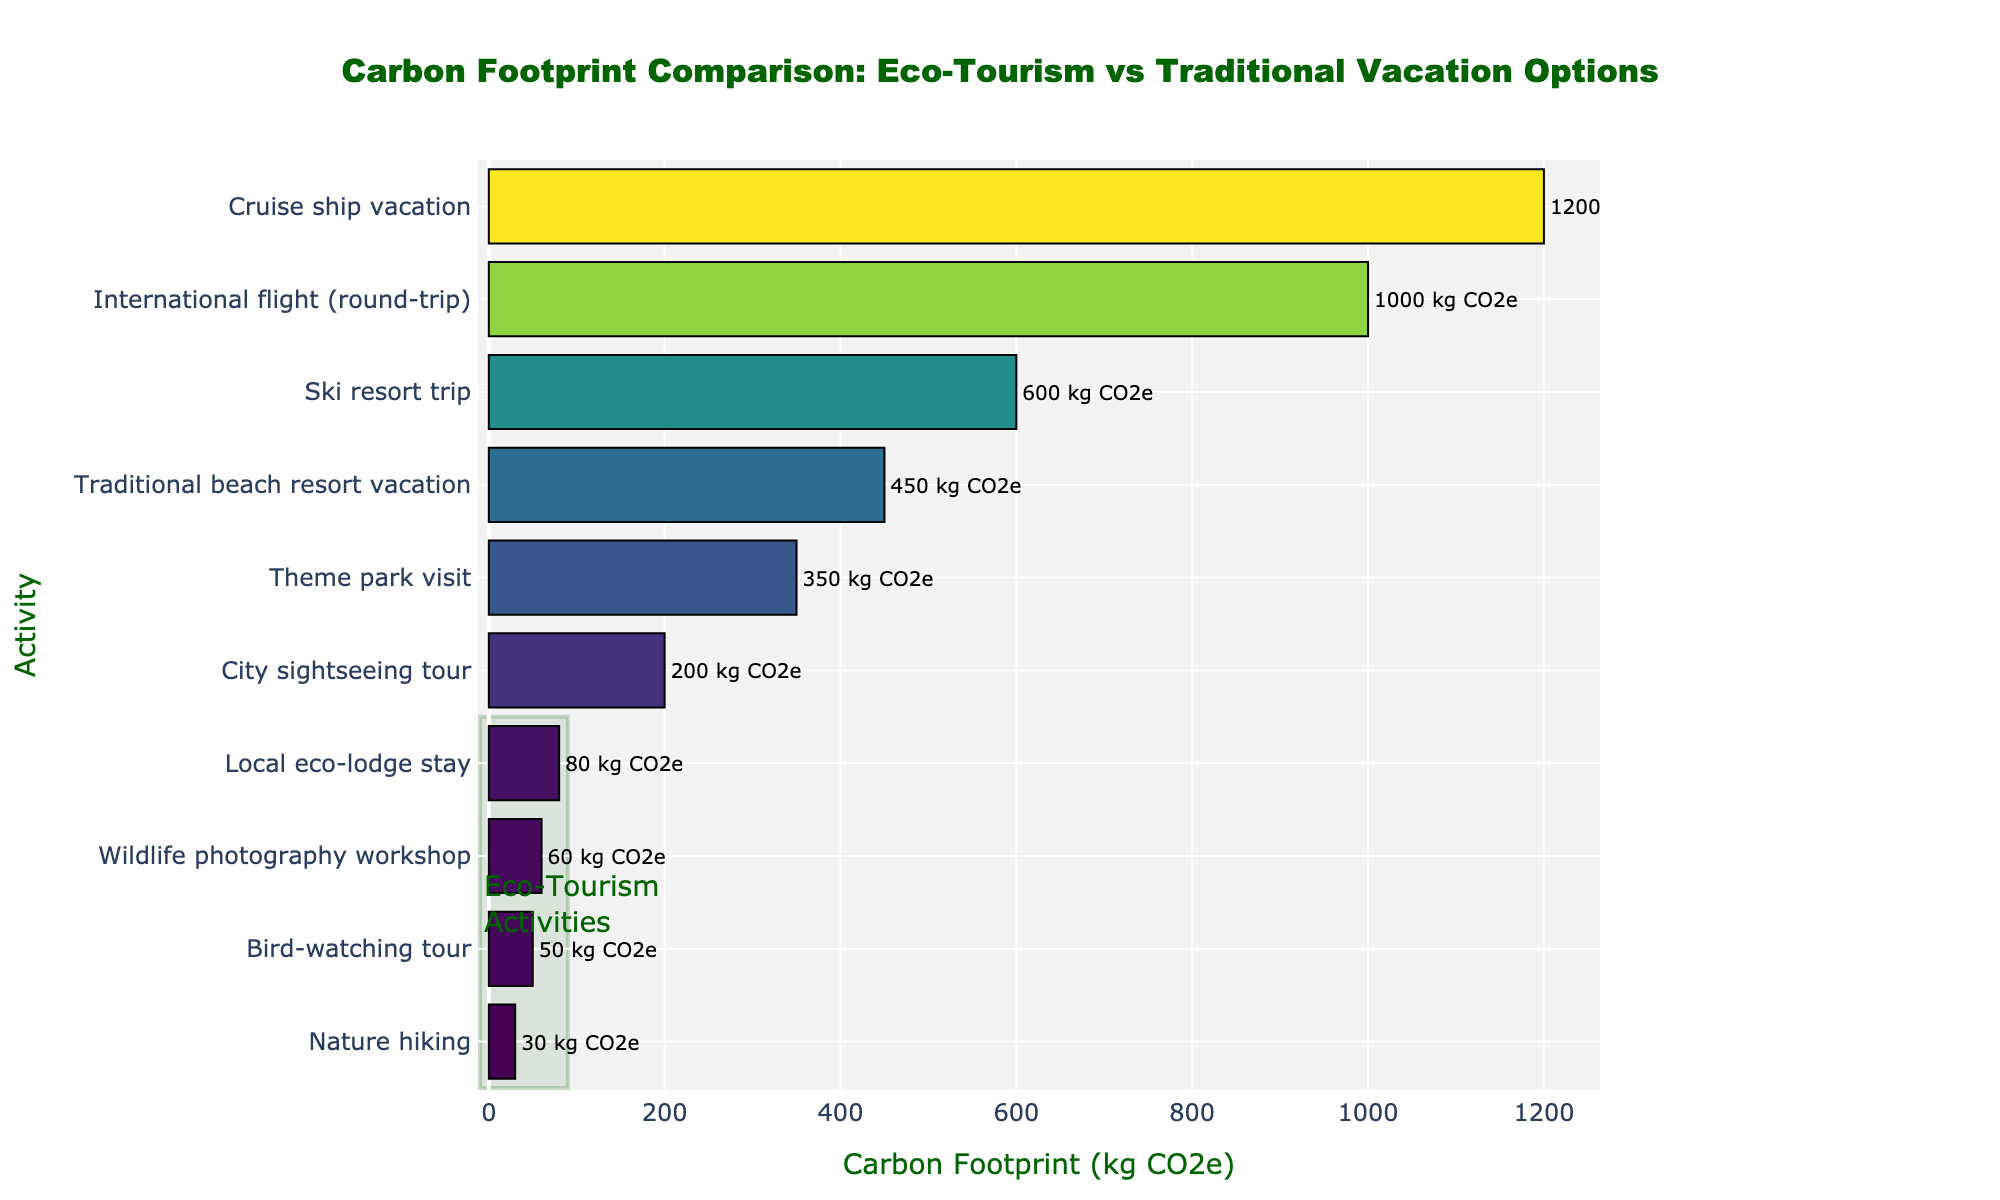What's the title of the figure? The title is usually at the top center of the plot. By looking at the top center, we can read the title "Carbon Footprint Comparison: Eco-Tourism vs Traditional Vacation Options"
Answer: Carbon Footprint Comparison: Eco-Tourism vs Traditional Vacation Options How many activities are compared in the figure? Count the number of different horizontal bars present in the plot. Each bar represents an activity. There are 10 bars, indicating 10 different activities compared.
Answer: 10 Which activity has the lowest carbon footprint? Look for the bar with the smallest length (it will be at the bottom due to ascending sorting). The label next to it reads "Nature hiking", which corresponds to the lowest carbon footprint.
Answer: Nature hiking What's the carbon footprint of a traditional beach resort vacation? Find the bar labeled "Traditional beach resort vacation" and read the numerical value (or look at the text label). The carbon footprint for this activity is given as "450 kg CO2e".
Answer: 450 kg CO2e What's the difference in carbon footprint between a bird-watching tour and a cruise ship vacation? Locate the bars for "Bird-watching tour" and "Cruise ship vacation". Bird-watching tour has a footprint of 50 kg CO2e and cruise ship vacation has 1200 kg CO2e. Subtract the smaller value from the larger: 1200 - 50. The difference is 1150 kg CO2e.
Answer: 1150 kg CO2e Which activity has the highest carbon footprint among eco-tourism activities? The eco-tourism activities are highlighted with a rectangle in the plot. Identify the bars within this rectangle and find the longest one. "Local eco-lodge stay" has a footprint of 80 kg CO2e, which is the highest among the eco-tourism options.
Answer: Local eco-lodge stay What's the median carbon footprint of all the activities? To find the median, list all carbon footprints in ascending order and find the middle value. The sorted values are 30, 50, 60, 80, 200, 350, 450, 600, 1000, 1200. The middle values are 200 and 350, so the median is the average of these two values: (200 + 350) / 2 = 275 kg CO2e.
Answer: 275 kg CO2e How does the carbon footprint of a city sightseeing tour compare to a theme park visit? Locate the bars for both activities. A city sightseeing tour has a footprint of 200 kg CO2e while a theme park visit has 350 kg CO2e. Comparing these, a city sightseeing tour has a lower carbon footprint.
Answer: A city sightseeing tour has a lower carbon footprint What percentage of the highest carbon footprint is the footprint of a bird-watching tour? Identify the highest carbon footprint (Cruise ship vacation at 1200 kg CO2e) and the footprint of a bird-watching tour (50 kg CO2e). Calculate the percentage: (50 / 1200) * 100%. The calculation results in approximately 4.17%.
Answer: 4.17% 